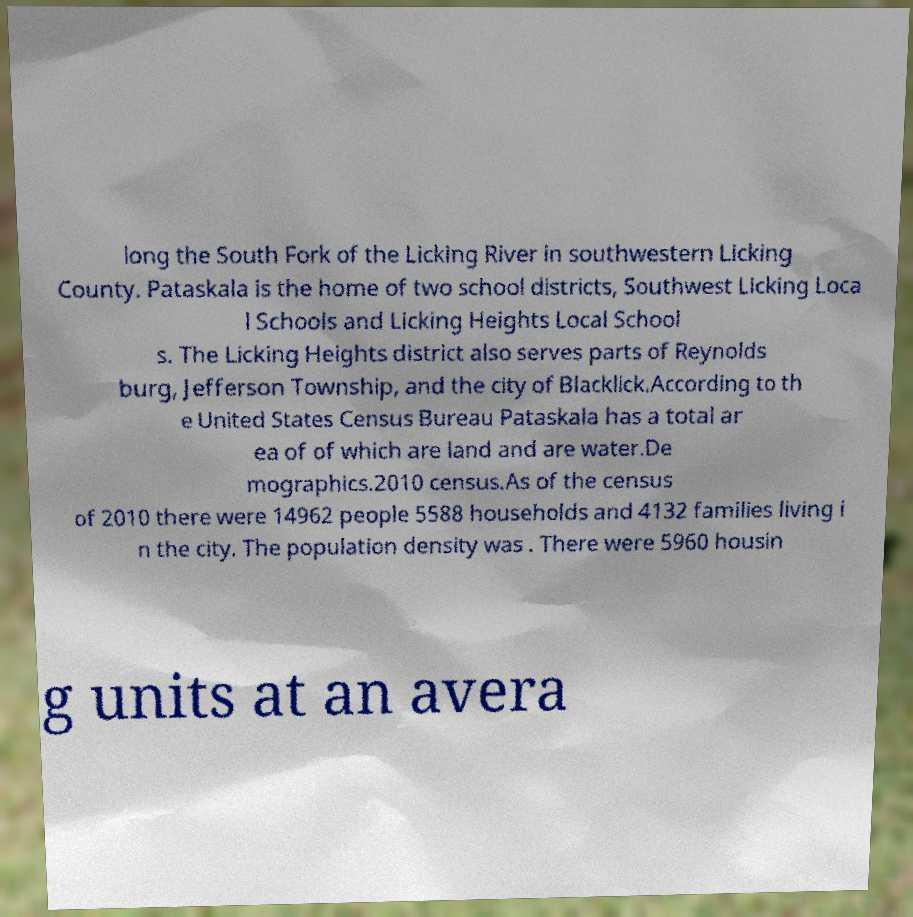For documentation purposes, I need the text within this image transcribed. Could you provide that? long the South Fork of the Licking River in southwestern Licking County. Pataskala is the home of two school districts, Southwest Licking Loca l Schools and Licking Heights Local School s. The Licking Heights district also serves parts of Reynolds burg, Jefferson Township, and the city of Blacklick.According to th e United States Census Bureau Pataskala has a total ar ea of of which are land and are water.De mographics.2010 census.As of the census of 2010 there were 14962 people 5588 households and 4132 families living i n the city. The population density was . There were 5960 housin g units at an avera 